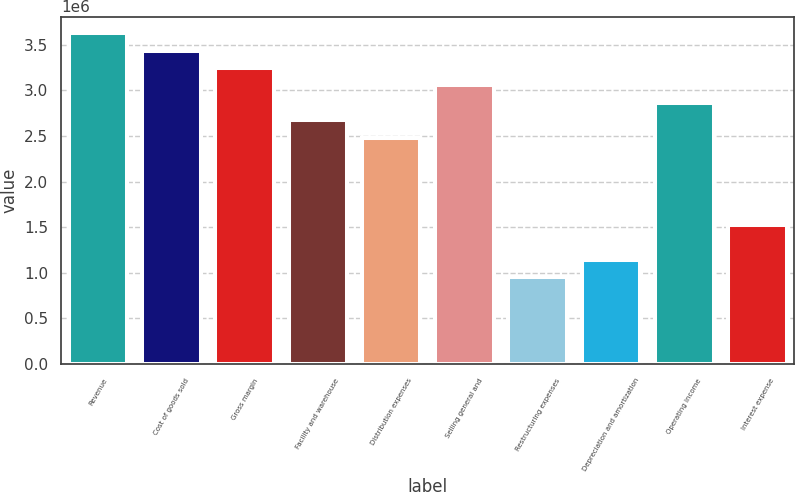<chart> <loc_0><loc_0><loc_500><loc_500><bar_chart><fcel>Revenue<fcel>Cost of goods sold<fcel>Gross margin<fcel>Facility and warehouse<fcel>Distribution expenses<fcel>Selling general and<fcel>Restructuring expenses<fcel>Depreciation and amortization<fcel>Operating income<fcel>Interest expense<nl><fcel>3.62621e+06<fcel>3.43536e+06<fcel>3.2445e+06<fcel>2.67194e+06<fcel>2.48109e+06<fcel>3.05365e+06<fcel>954266<fcel>1.14512e+06<fcel>2.8628e+06<fcel>1.52683e+06<nl></chart> 